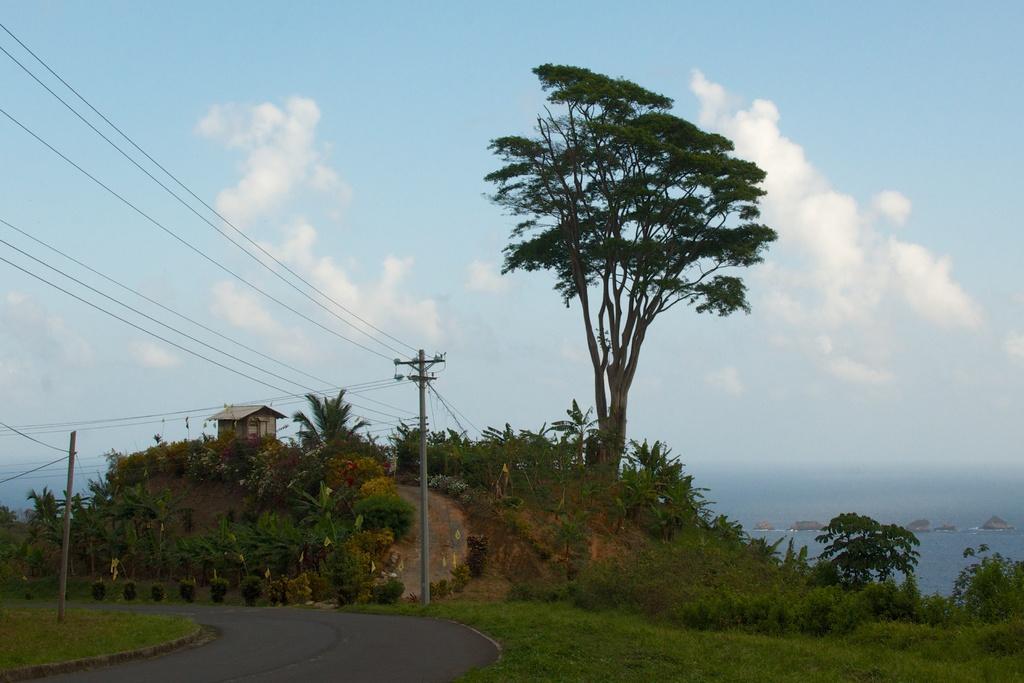Can you describe this image briefly? In this picture there is a way and grassland at the bottom side of the image and there are poles, wires and plants in the image, there is a tree and a hut, there are stones and water in the background area of the image, there is sky in the image. 